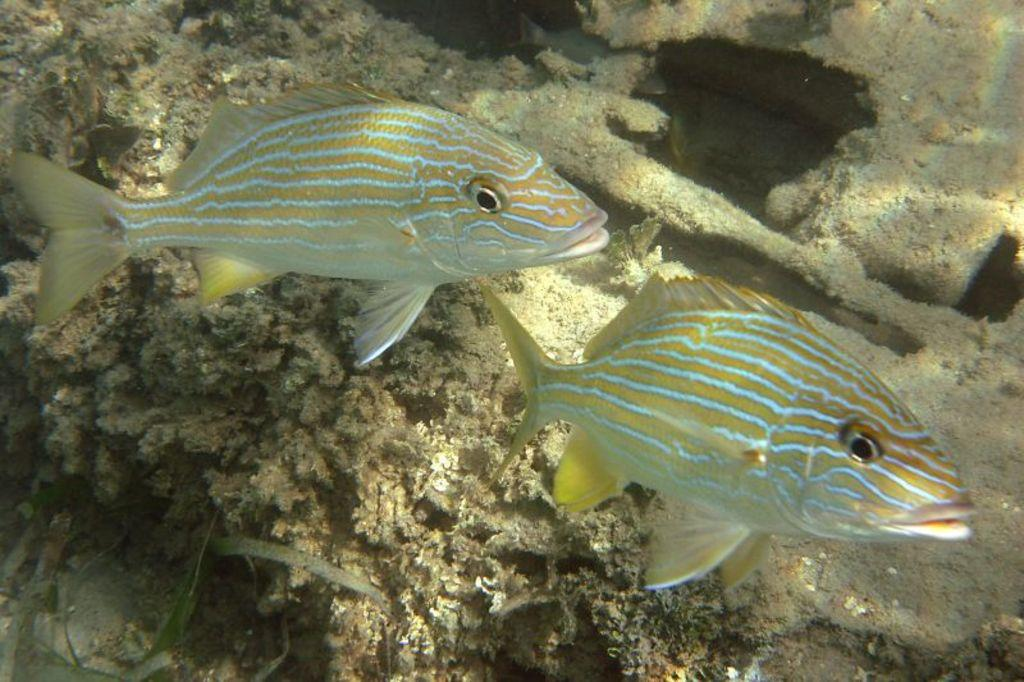What animals are present in the image? There are two fishes in the image. Where was the image taken? The image was taken underwater. What type of vegetation can be seen at the bottom of the image? There are coral plants at the bottom of the image. What type of bead is being used to balance the body in the image? There is no bead or body present in the image; it features two fishes and coral plants underwater. 